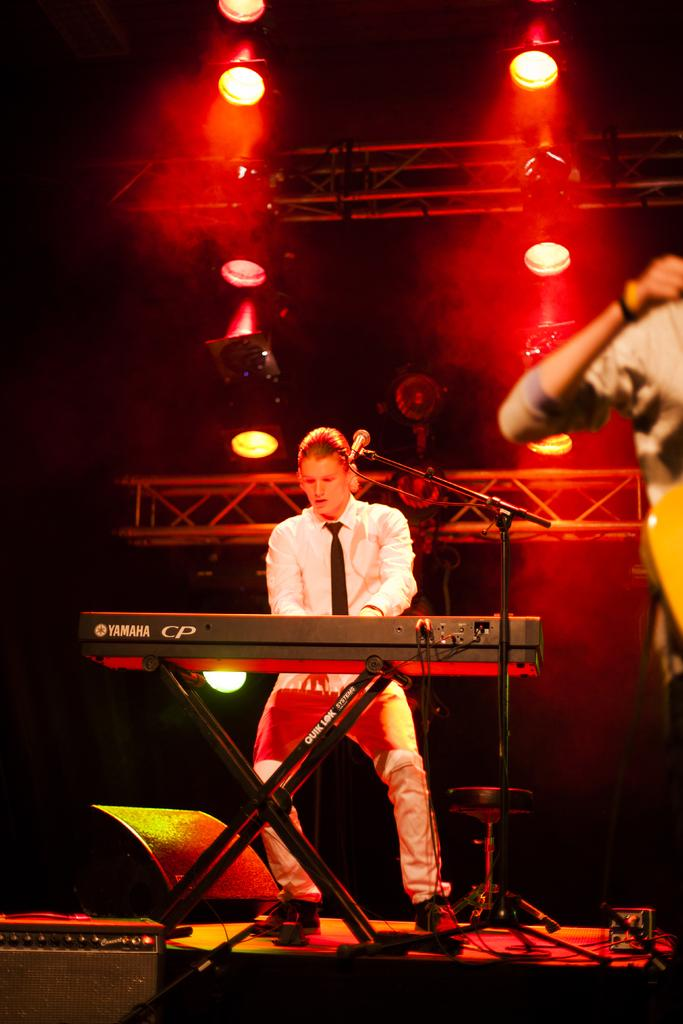What is the man in the image doing? The man is standing and playing a guitar. Can you describe the background of the image? There are lights attached to the ceiling and iron frames in the background. How many clocks can be seen hanging from the iron frames in the image? There are no clocks visible in the image; only lights and iron frames are present in the background. 